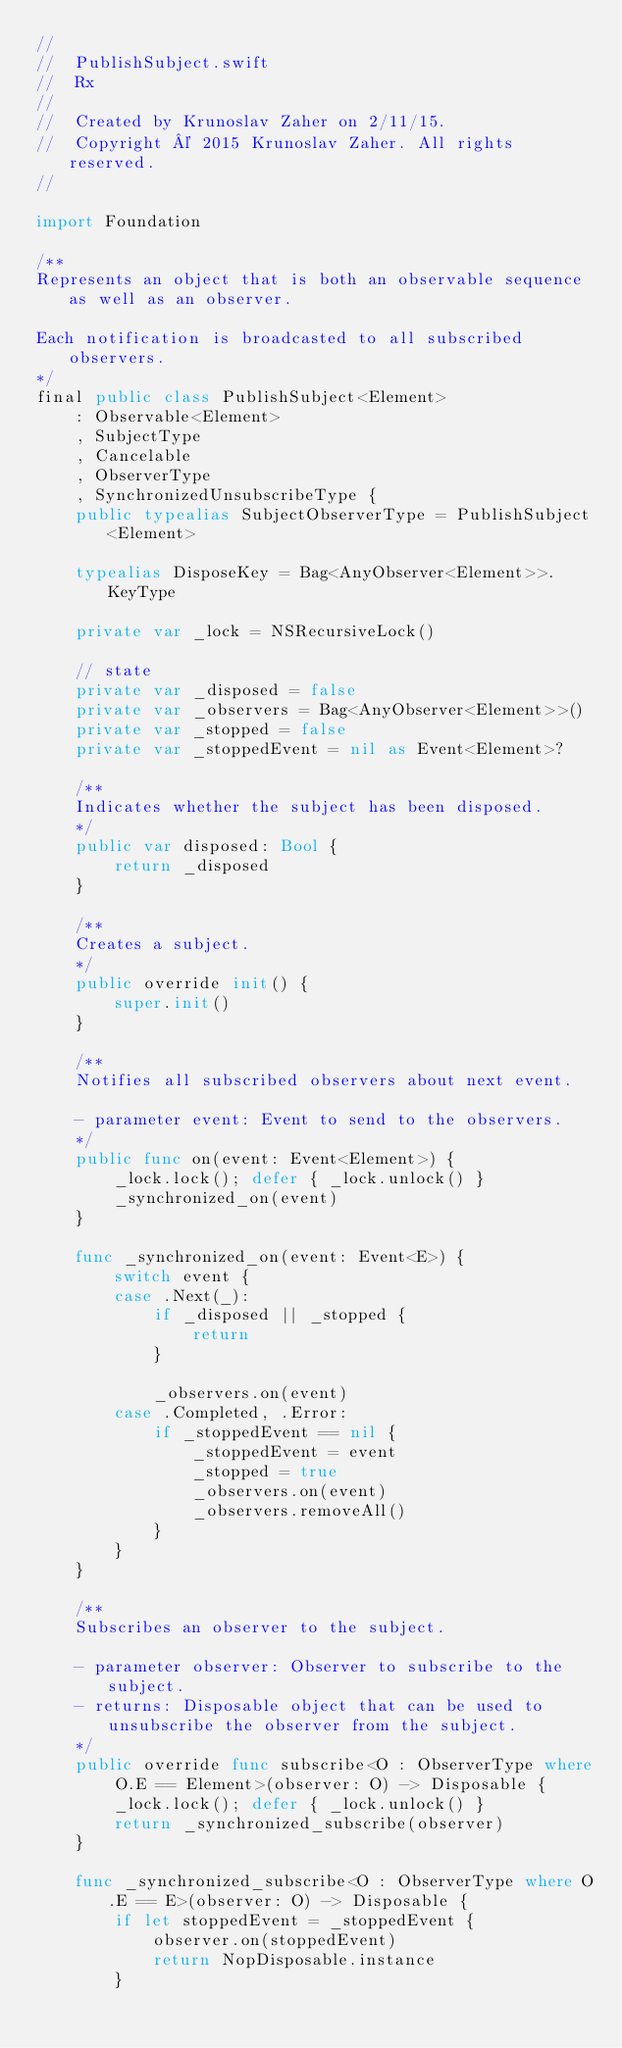Convert code to text. <code><loc_0><loc_0><loc_500><loc_500><_Swift_>//
//  PublishSubject.swift
//  Rx
//
//  Created by Krunoslav Zaher on 2/11/15.
//  Copyright © 2015 Krunoslav Zaher. All rights reserved.
//

import Foundation

/**
Represents an object that is both an observable sequence as well as an observer.

Each notification is broadcasted to all subscribed observers.
*/
final public class PublishSubject<Element>
    : Observable<Element>
    , SubjectType
    , Cancelable
    , ObserverType
    , SynchronizedUnsubscribeType {
    public typealias SubjectObserverType = PublishSubject<Element>
    
    typealias DisposeKey = Bag<AnyObserver<Element>>.KeyType
    
    private var _lock = NSRecursiveLock()
    
    // state
    private var _disposed = false
    private var _observers = Bag<AnyObserver<Element>>()
    private var _stopped = false
    private var _stoppedEvent = nil as Event<Element>?
    
    /**
    Indicates whether the subject has been disposed.
    */
    public var disposed: Bool {
        return _disposed
    }
    
    /**
    Creates a subject.
    */
    public override init() {
        super.init()
    }
    
    /**
    Notifies all subscribed observers about next event.
    
    - parameter event: Event to send to the observers.
    */
    public func on(event: Event<Element>) {
        _lock.lock(); defer { _lock.unlock() }
        _synchronized_on(event)
    }

    func _synchronized_on(event: Event<E>) {
        switch event {
        case .Next(_):
            if _disposed || _stopped {
                return
            }
            
            _observers.on(event)
        case .Completed, .Error:
            if _stoppedEvent == nil {
                _stoppedEvent = event
                _stopped = true
                _observers.on(event)
                _observers.removeAll()
            }
        }
    }
    
    /**
    Subscribes an observer to the subject.
    
    - parameter observer: Observer to subscribe to the subject.
    - returns: Disposable object that can be used to unsubscribe the observer from the subject.
    */
    public override func subscribe<O : ObserverType where O.E == Element>(observer: O) -> Disposable {
        _lock.lock(); defer { _lock.unlock() }
        return _synchronized_subscribe(observer)
    }

    func _synchronized_subscribe<O : ObserverType where O.E == E>(observer: O) -> Disposable {
        if let stoppedEvent = _stoppedEvent {
            observer.on(stoppedEvent)
            return NopDisposable.instance
        }
        </code> 